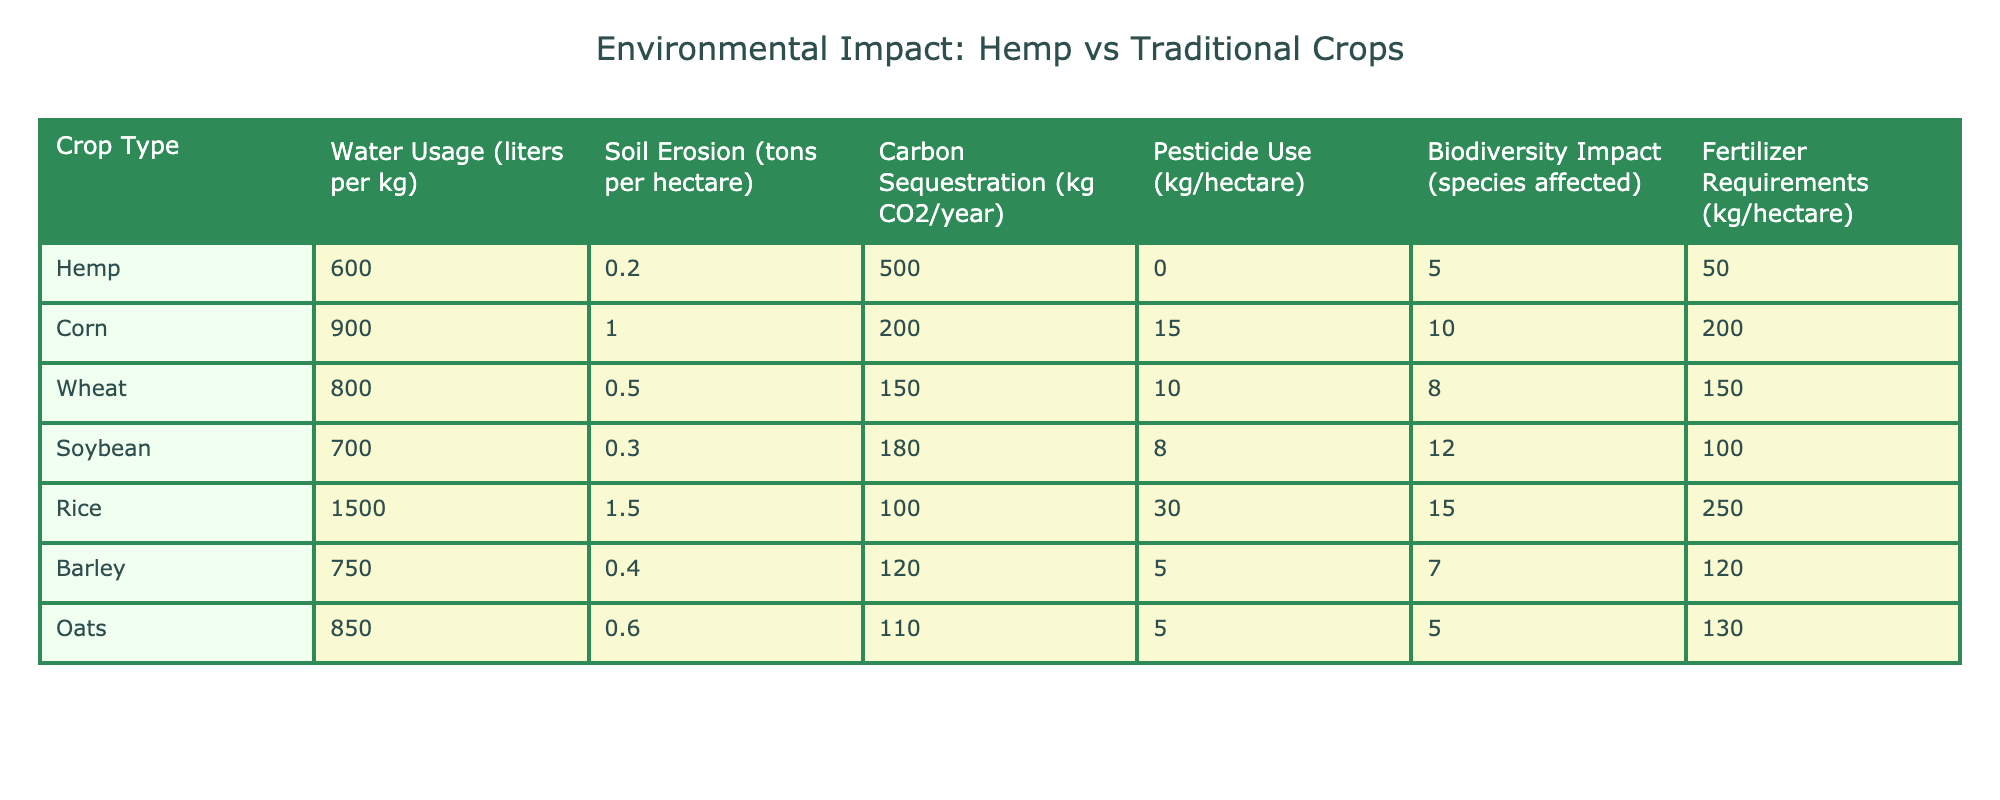What is the water usage per kilogram for hemp? The table shows that the water usage for hemp is listed as 600 liters per kg.
Answer: 600 liters per kg How much soil erosion does corn cause per hectare? Corn is associated with soil erosion of 1.0 tons per hectare as per the data in the table.
Answer: 1.0 tons per hectare Which crop has the highest pesticide use? By examining the table, it's clear that rice has the highest pesticide use at 30 kg per hectare.
Answer: Rice What is the average carbon sequestration for traditional crops? The traditional crops listed are corn, wheat, soybean, rice, barley, and oats. Their carbon sequestration values are 200, 150, 180, 100, 120, and 110 kg CO2/year respectively. To find the average, sum these values (200 + 150 + 180 + 100 + 120 + 110 = 960) and divide by the number of crops (960 / 6 = 160).
Answer: 160 kg CO2/year Does hemp use any pesticides? The table indicates that hemp's pesticide use is listed as 0 kg per hectare, which confirms that no pesticides are used.
Answer: Yes What is the difference in soil erosion between soybean and barley? The soil erosion for soybean is 0.3 tons per hectare, while for barley it is 0.4 tons per hectare. The difference is calculated as 0.4 - 0.3 = 0.1 tons per hectare.
Answer: 0.1 tons per hectare Which crop affects the least number of species in terms of biodiversity impact? The table shows that hemp affects 5 species, which is the lowest number compared to other crops (corn, 10; wheat, 8; soybean, 12; rice, 15; barley, 7; oats, 5).
Answer: Hemp How much more fertilizer does corn require compared to hemp? Corn requires 200 kg per hectare while hemp requires 50 kg per hectare. The difference in fertilizer requirements is 200 - 50 = 150 kg per hectare.
Answer: 150 kg per hectare Which crop sequesters more carbon: wheat or barley? Wheat sequesters 150 kg CO2/year, and barley sequesters 120 kg CO2/year. Since 150 is greater than 120, wheat sequesters more carbon.
Answer: Wheat If we consider all crops in the table, which one has the lowest water usage? The table indicates that hemp has the lowest water usage at 600 liters per kg compared to all other crops listed.
Answer: Hemp 